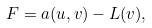Convert formula to latex. <formula><loc_0><loc_0><loc_500><loc_500>F = a ( u , v ) - L ( v ) ,</formula> 